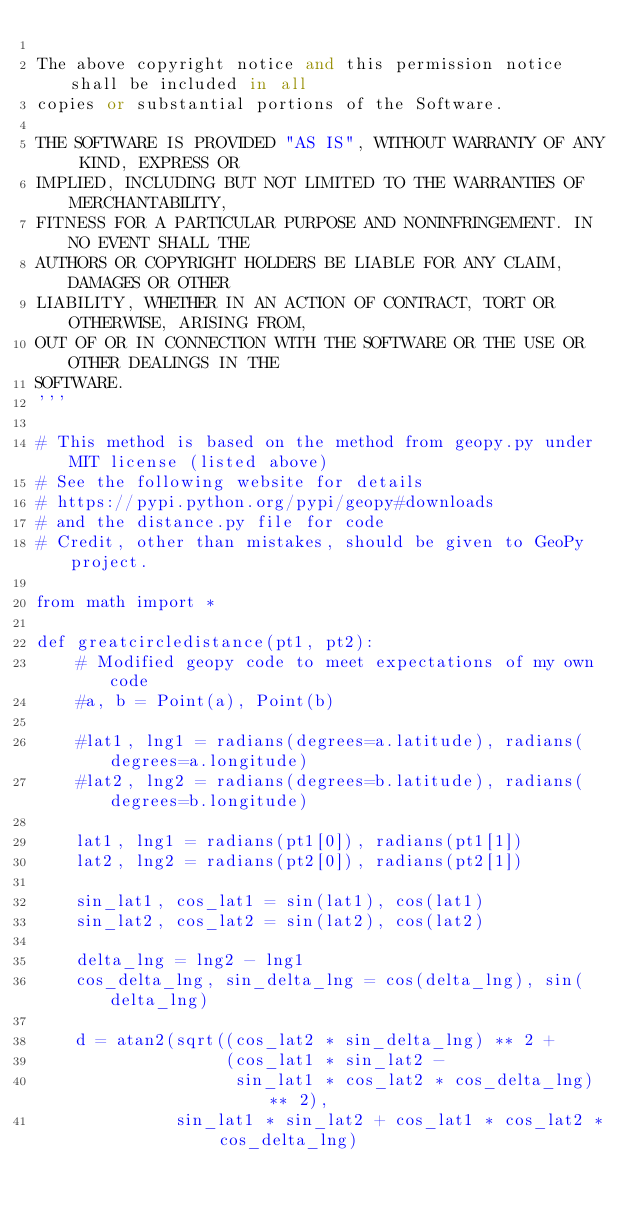<code> <loc_0><loc_0><loc_500><loc_500><_Python_>
The above copyright notice and this permission notice shall be included in all
copies or substantial portions of the Software.

THE SOFTWARE IS PROVIDED "AS IS", WITHOUT WARRANTY OF ANY KIND, EXPRESS OR
IMPLIED, INCLUDING BUT NOT LIMITED TO THE WARRANTIES OF MERCHANTABILITY,
FITNESS FOR A PARTICULAR PURPOSE AND NONINFRINGEMENT. IN NO EVENT SHALL THE
AUTHORS OR COPYRIGHT HOLDERS BE LIABLE FOR ANY CLAIM, DAMAGES OR OTHER
LIABILITY, WHETHER IN AN ACTION OF CONTRACT, TORT OR OTHERWISE, ARISING FROM,
OUT OF OR IN CONNECTION WITH THE SOFTWARE OR THE USE OR OTHER DEALINGS IN THE
SOFTWARE.
'''

# This method is based on the method from geopy.py under MIT license (listed above)
# See the following website for details
# https://pypi.python.org/pypi/geopy#downloads
# and the distance.py file for code
# Credit, other than mistakes, should be given to GeoPy project.

from math import *

def greatcircledistance(pt1, pt2):
    # Modified geopy code to meet expectations of my own code
    #a, b = Point(a), Point(b)

    #lat1, lng1 = radians(degrees=a.latitude), radians(degrees=a.longitude)
    #lat2, lng2 = radians(degrees=b.latitude), radians(degrees=b.longitude)

    lat1, lng1 = radians(pt1[0]), radians(pt1[1])
    lat2, lng2 = radians(pt2[0]), radians(pt2[1])

    sin_lat1, cos_lat1 = sin(lat1), cos(lat1)
    sin_lat2, cos_lat2 = sin(lat2), cos(lat2)

    delta_lng = lng2 - lng1
    cos_delta_lng, sin_delta_lng = cos(delta_lng), sin(delta_lng)

    d = atan2(sqrt((cos_lat2 * sin_delta_lng) ** 2 +
                   (cos_lat1 * sin_lat2 -
                    sin_lat1 * cos_lat2 * cos_delta_lng) ** 2),
              sin_lat1 * sin_lat2 + cos_lat1 * cos_lat2 * cos_delta_lng)
</code> 